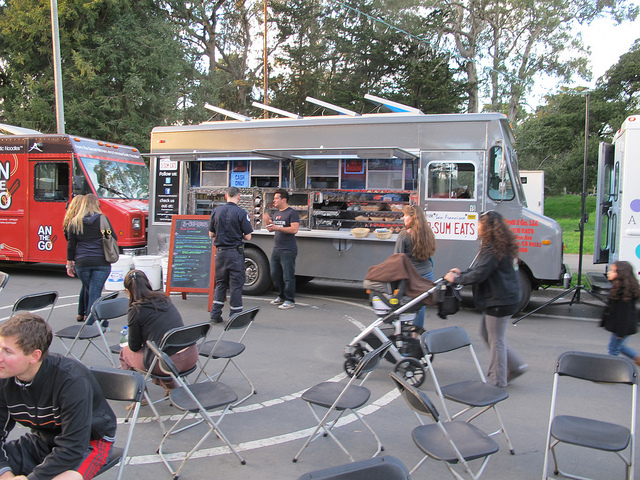How many autos are there? There are no automobiles visible in the image. The scene shows a food truck with customers around it, and other elements such as chairs and a bicycle. 